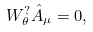<formula> <loc_0><loc_0><loc_500><loc_500>W ^ { ? } _ { \theta } \hat { A } _ { \mu } = 0 ,</formula> 